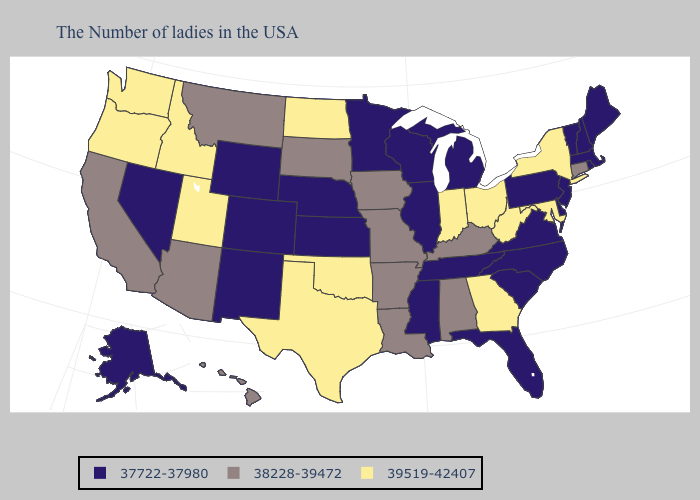Name the states that have a value in the range 37722-37980?
Keep it brief. Maine, Massachusetts, Rhode Island, New Hampshire, Vermont, New Jersey, Delaware, Pennsylvania, Virginia, North Carolina, South Carolina, Florida, Michigan, Tennessee, Wisconsin, Illinois, Mississippi, Minnesota, Kansas, Nebraska, Wyoming, Colorado, New Mexico, Nevada, Alaska. What is the lowest value in the West?
Keep it brief. 37722-37980. Does Oklahoma have a higher value than Maryland?
Be succinct. No. What is the lowest value in the MidWest?
Be succinct. 37722-37980. Among the states that border Kentucky , which have the highest value?
Concise answer only. West Virginia, Ohio, Indiana. Which states hav the highest value in the MidWest?
Answer briefly. Ohio, Indiana, North Dakota. Does South Dakota have the same value as Delaware?
Write a very short answer. No. What is the value of Nevada?
Be succinct. 37722-37980. What is the value of Maryland?
Concise answer only. 39519-42407. How many symbols are there in the legend?
Be succinct. 3. Name the states that have a value in the range 38228-39472?
Keep it brief. Connecticut, Kentucky, Alabama, Louisiana, Missouri, Arkansas, Iowa, South Dakota, Montana, Arizona, California, Hawaii. Name the states that have a value in the range 37722-37980?
Give a very brief answer. Maine, Massachusetts, Rhode Island, New Hampshire, Vermont, New Jersey, Delaware, Pennsylvania, Virginia, North Carolina, South Carolina, Florida, Michigan, Tennessee, Wisconsin, Illinois, Mississippi, Minnesota, Kansas, Nebraska, Wyoming, Colorado, New Mexico, Nevada, Alaska. What is the lowest value in the USA?
Be succinct. 37722-37980. Among the states that border Mississippi , does Tennessee have the highest value?
Quick response, please. No. Does Iowa have the highest value in the USA?
Write a very short answer. No. 